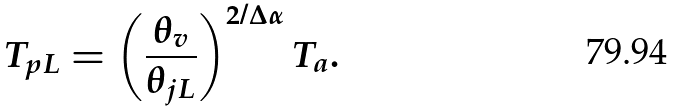Convert formula to latex. <formula><loc_0><loc_0><loc_500><loc_500>T _ { p L } = \left ( \frac { \theta _ { v } } { \theta _ { j L } } \right ) ^ { 2 / \Delta \alpha } T _ { a } .</formula> 